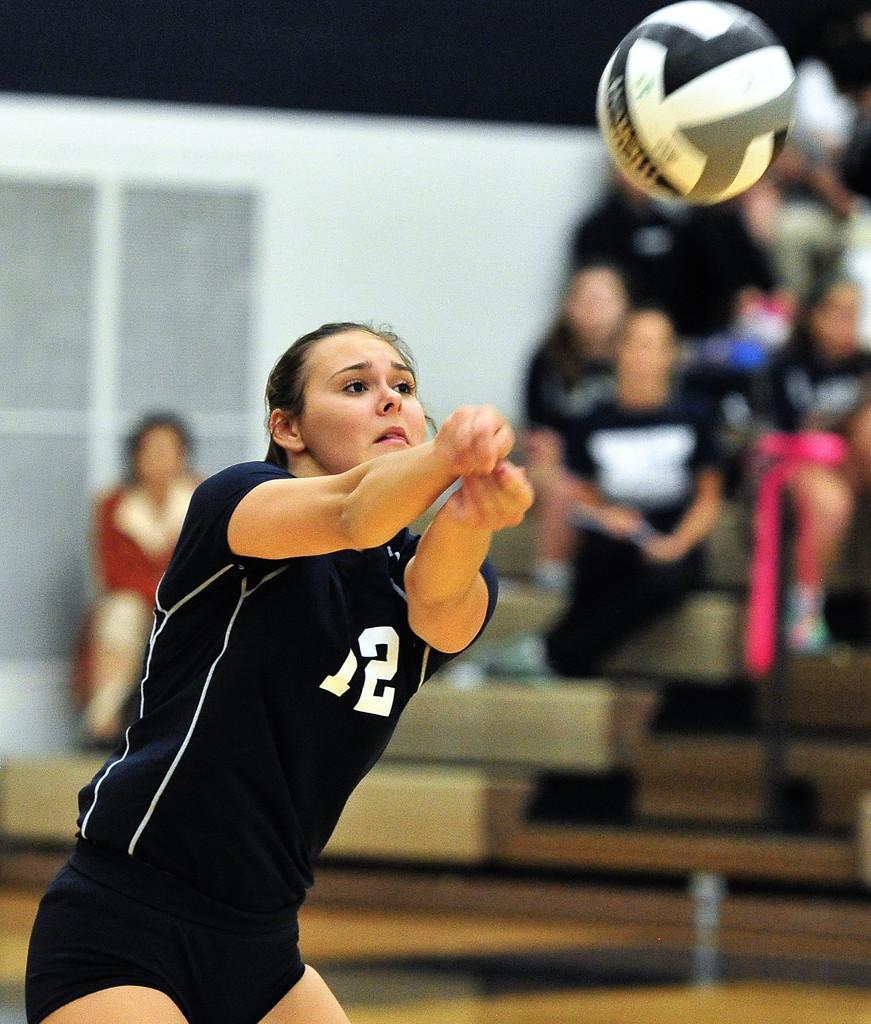In one or two sentences, can you explain what this image depicts? In this image there is a person sitting and there is a window on the left corner. We can see a person and a ball. There are people sitting on the right corner. There is a wall in the background. 